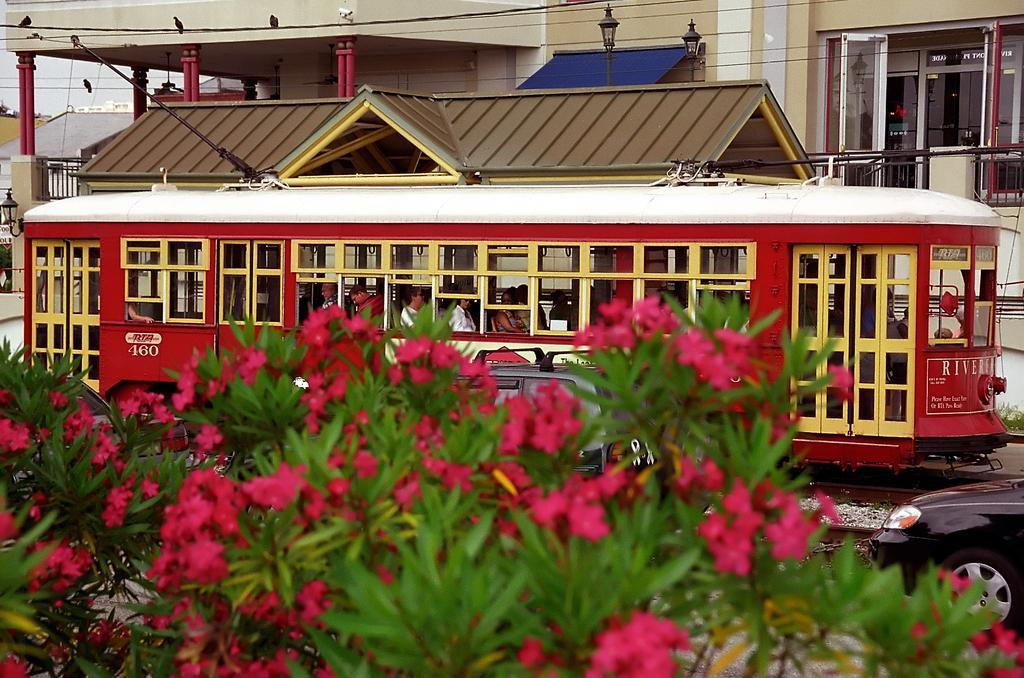What type of plants can be seen in the image? There are flower plants in the image. What can be seen in the background of the image? There are cars on a road, a train on a track, and houses in the background. What type of card is being used to cut the meat in the image? There is no card or meat present in the image. 